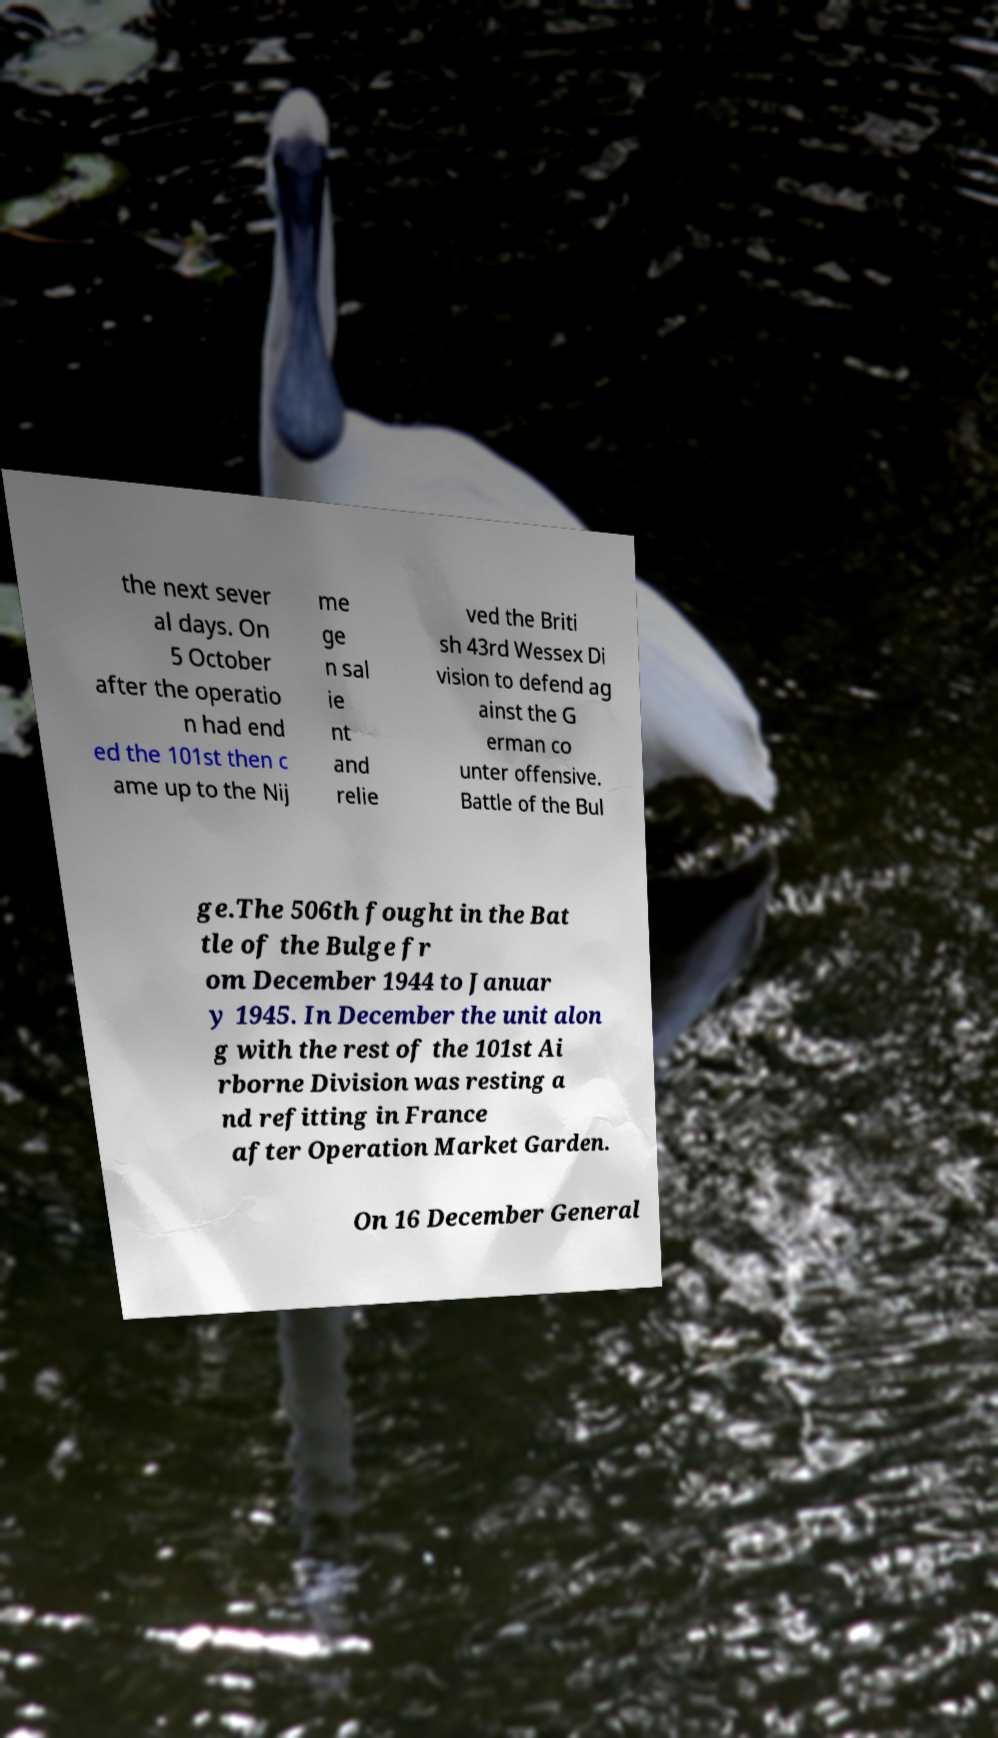Please read and relay the text visible in this image. What does it say? the next sever al days. On 5 October after the operatio n had end ed the 101st then c ame up to the Nij me ge n sal ie nt and relie ved the Briti sh 43rd Wessex Di vision to defend ag ainst the G erman co unter offensive. Battle of the Bul ge.The 506th fought in the Bat tle of the Bulge fr om December 1944 to Januar y 1945. In December the unit alon g with the rest of the 101st Ai rborne Division was resting a nd refitting in France after Operation Market Garden. On 16 December General 